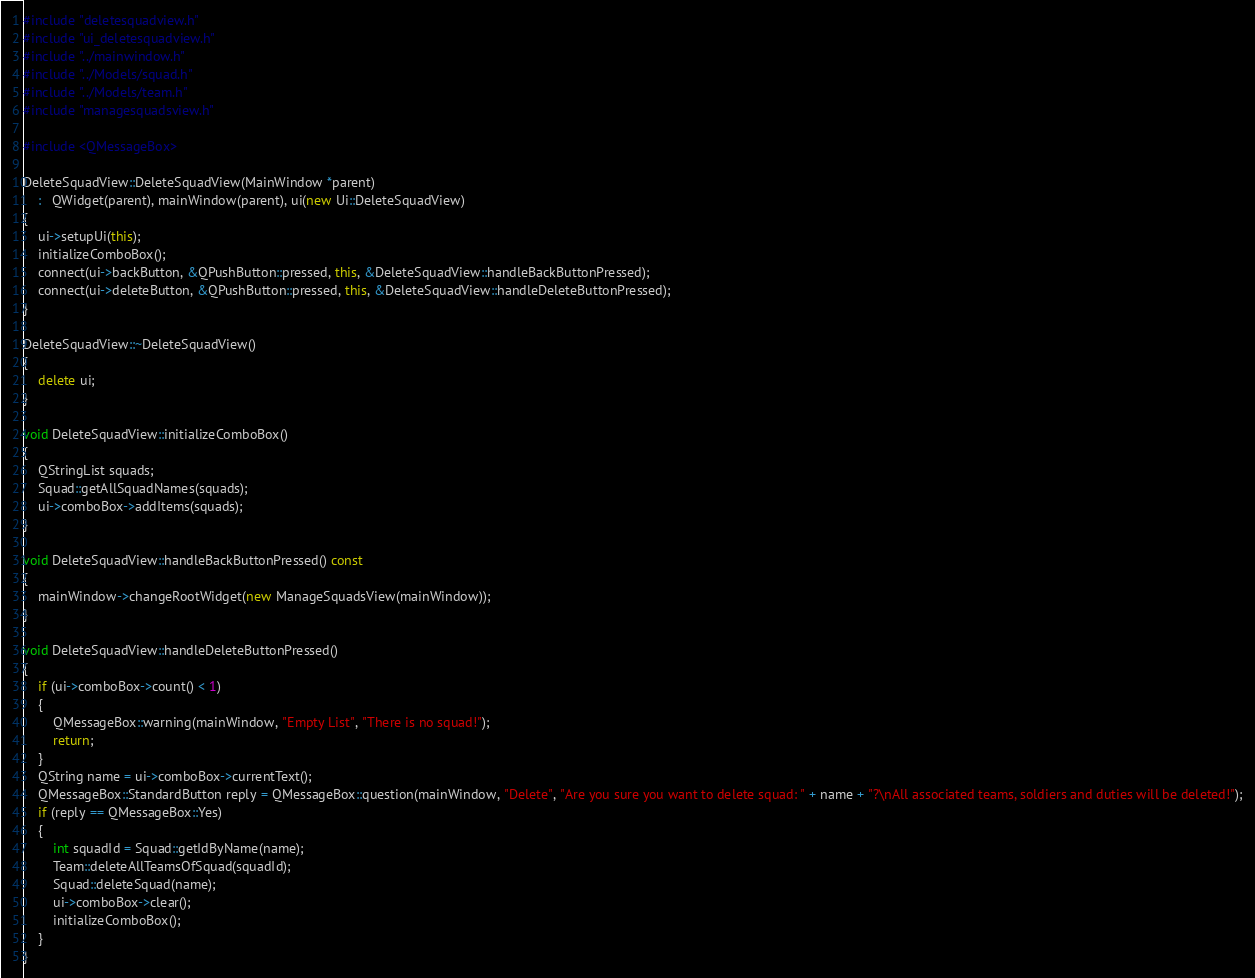<code> <loc_0><loc_0><loc_500><loc_500><_C++_>#include "deletesquadview.h"
#include "ui_deletesquadview.h"
#include "../mainwindow.h"
#include "../Models/squad.h"
#include "../Models/team.h"
#include "managesquadsview.h"

#include <QMessageBox>

DeleteSquadView::DeleteSquadView(MainWindow *parent)
    :   QWidget(parent), mainWindow(parent), ui(new Ui::DeleteSquadView)
{
    ui->setupUi(this);
    initializeComboBox();
    connect(ui->backButton, &QPushButton::pressed, this, &DeleteSquadView::handleBackButtonPressed);
    connect(ui->deleteButton, &QPushButton::pressed, this, &DeleteSquadView::handleDeleteButtonPressed);
}

DeleteSquadView::~DeleteSquadView()
{
    delete ui;
}

void DeleteSquadView::initializeComboBox()
{
    QStringList squads;
    Squad::getAllSquadNames(squads);
    ui->comboBox->addItems(squads);
}

void DeleteSquadView::handleBackButtonPressed() const
{
    mainWindow->changeRootWidget(new ManageSquadsView(mainWindow));
}

void DeleteSquadView::handleDeleteButtonPressed()
{
    if (ui->comboBox->count() < 1)
    {
        QMessageBox::warning(mainWindow, "Empty List", "There is no squad!");
        return;
    }
    QString name = ui->comboBox->currentText();
    QMessageBox::StandardButton reply = QMessageBox::question(mainWindow, "Delete", "Are you sure you want to delete squad: " + name + "?\nAll associated teams, soldiers and duties will be deleted!");
    if (reply == QMessageBox::Yes)
    {
        int squadId = Squad::getIdByName(name);
        Team::deleteAllTeamsOfSquad(squadId);
        Squad::deleteSquad(name);
        ui->comboBox->clear();
        initializeComboBox();
    }
}
</code> 